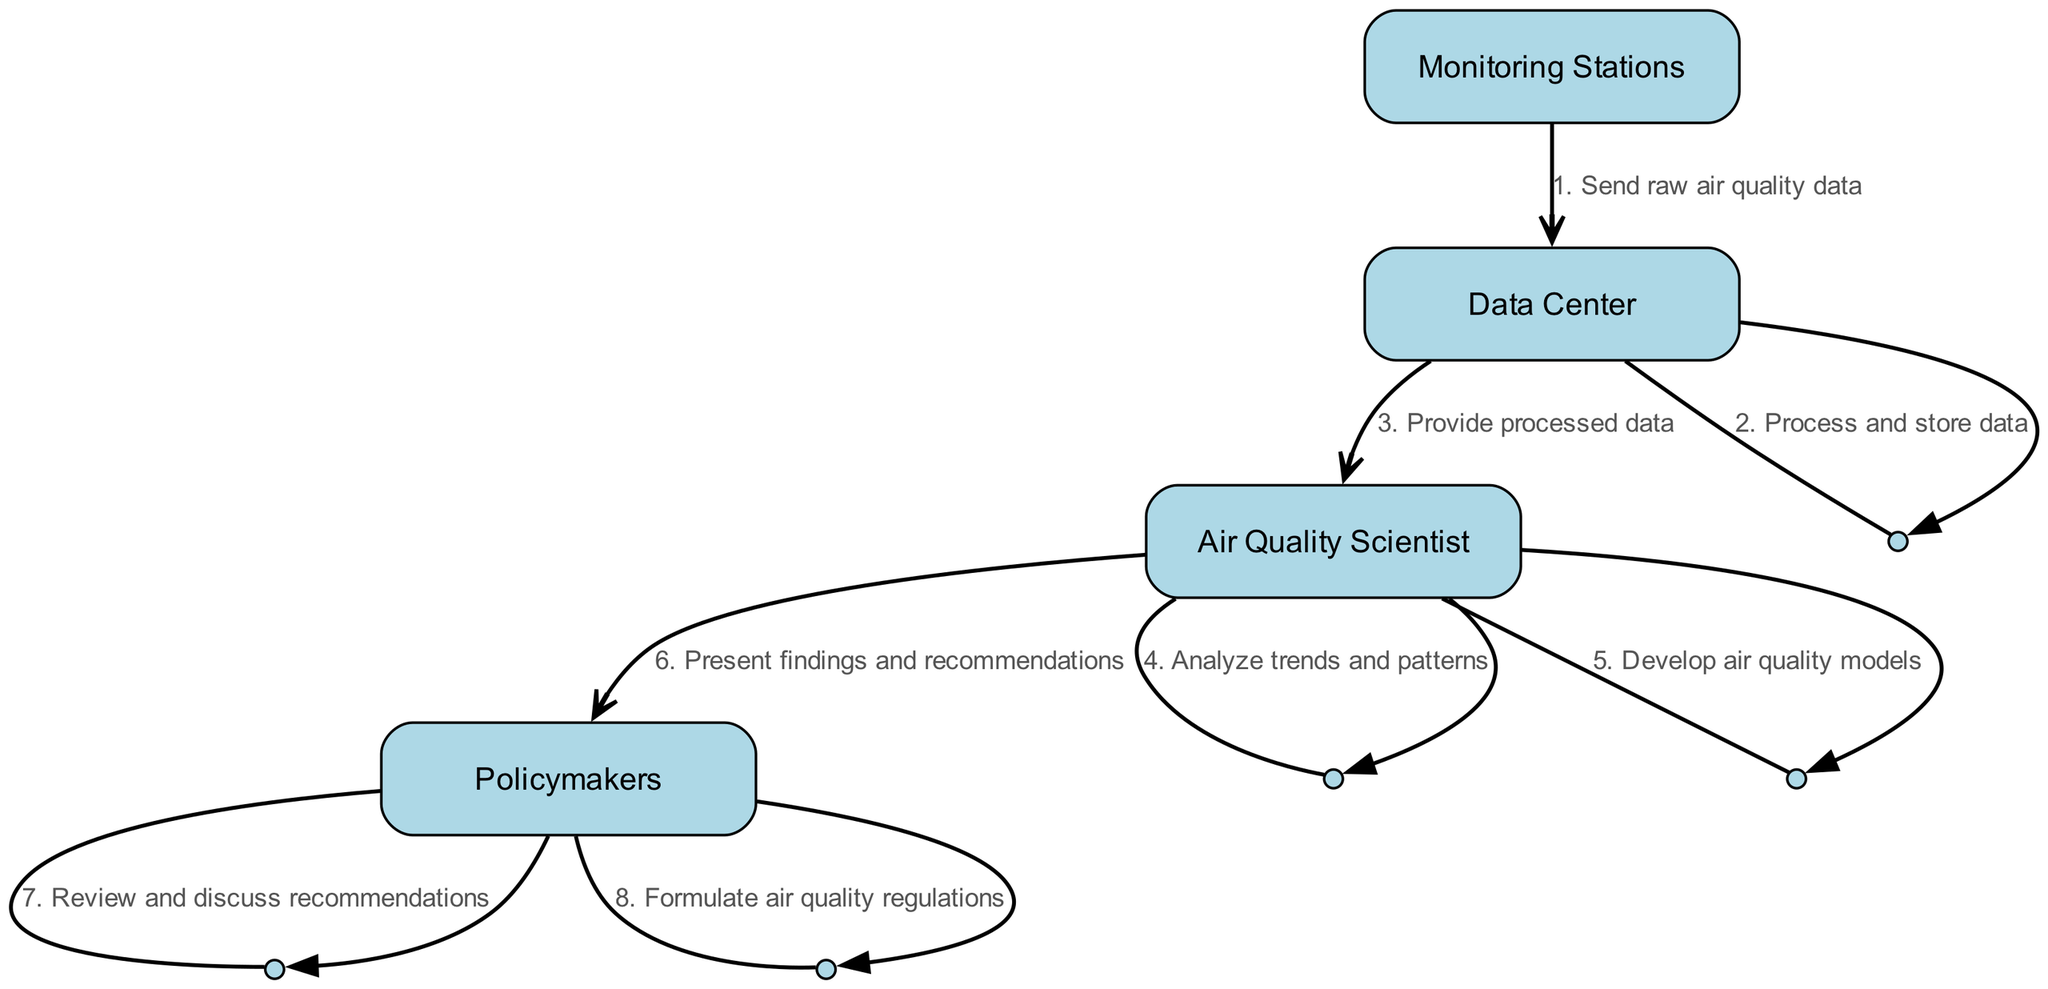What is the first action in the process? The first action is between the Monitoring Stations and the Data Center, where the Monitoring Stations send raw air quality data to the Data Center.
Answer: Send raw air quality data How many actors are involved in the air quality monitoring process? The diagram shows four actors: Monitoring Stations, Data Center, Air Quality Scientist, and Policymakers.
Answer: Four What does the Data Center do with the raw air quality data? The Data Center processes and stores the data after receiving it from the Monitoring Stations.
Answer: Process and store data Which actor presents findings and recommendations? The Air Quality Scientist is responsible for presenting findings and recommendations to the Policymakers.
Answer: Air Quality Scientist What action follows the analysis of trends and patterns? After analyzing trends and patterns, the Air Quality Scientist develops air quality models. This indicates a sequential progression where modeling follows analysis.
Answer: Develop air quality models How many edges are going from the Air Quality Scientist to the Policymakers? There are two actions directed from the Air Quality Scientist to the Policymakers: first, presenting findings and recommendations, and then those recommendations are discussed.
Answer: Two Who is involved in reviewing and discussing recommendations? The Policymakers are the ones who review and discuss the recommendations presented by the Air Quality Scientist.
Answer: Policymakers What is the last action in the sequence diagram? The final action in the diagram is the Policymakers formulating air quality regulations based on the previous discussions and recommendations.
Answer: Formulate air quality regulations What type of diagram is used to represent this process? The diagram used is a sequence diagram, as it illustrates the order of interactions among actors across time.
Answer: Sequence diagram 